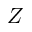<formula> <loc_0><loc_0><loc_500><loc_500>Z</formula> 